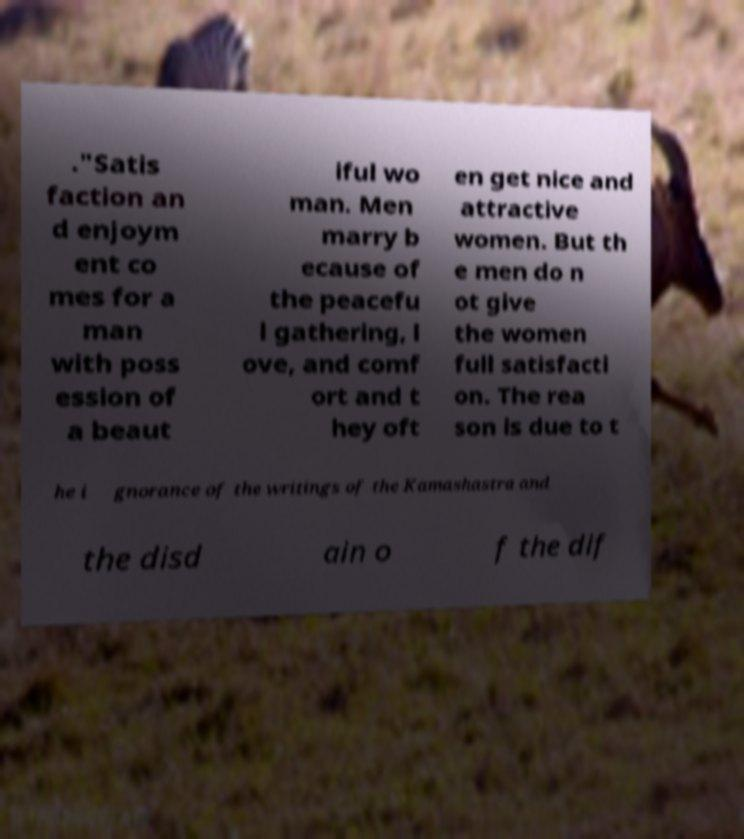Can you accurately transcribe the text from the provided image for me? ."Satis faction an d enjoym ent co mes for a man with poss ession of a beaut iful wo man. Men marry b ecause of the peacefu l gathering, l ove, and comf ort and t hey oft en get nice and attractive women. But th e men do n ot give the women full satisfacti on. The rea son is due to t he i gnorance of the writings of the Kamashastra and the disd ain o f the dif 